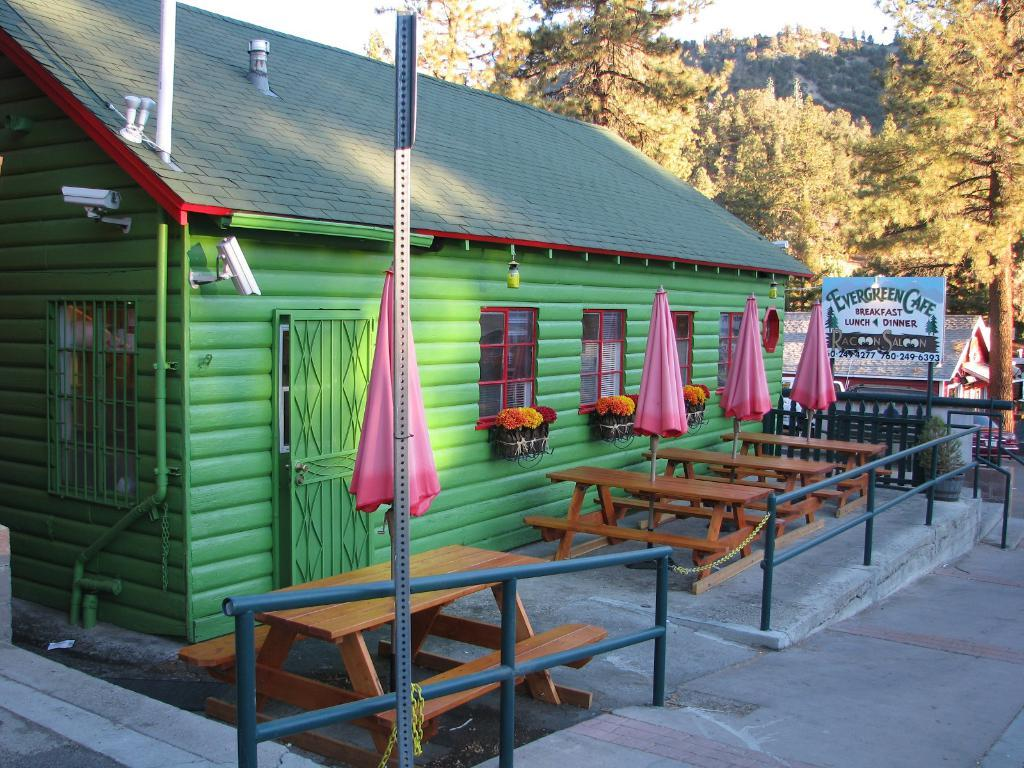What type of structure is visible in the image? There is a house in the image. What features can be seen on the house? The house has windows. What type of vegetation is present in the image? There are trees in the image. What type of material is used for the objects in the image? There are wooden objects in the image. What type of barrier is present in the image? There is a fence in the image. What type of stands are visible in the image? There are stands with cloth in the image. How many girls are holding bananas in the image? There are no girls or bananas present in the image. What type of porter is carrying the wooden objects in the image? There is no porter present in the image, and the wooden objects are not being carried by anyone. 